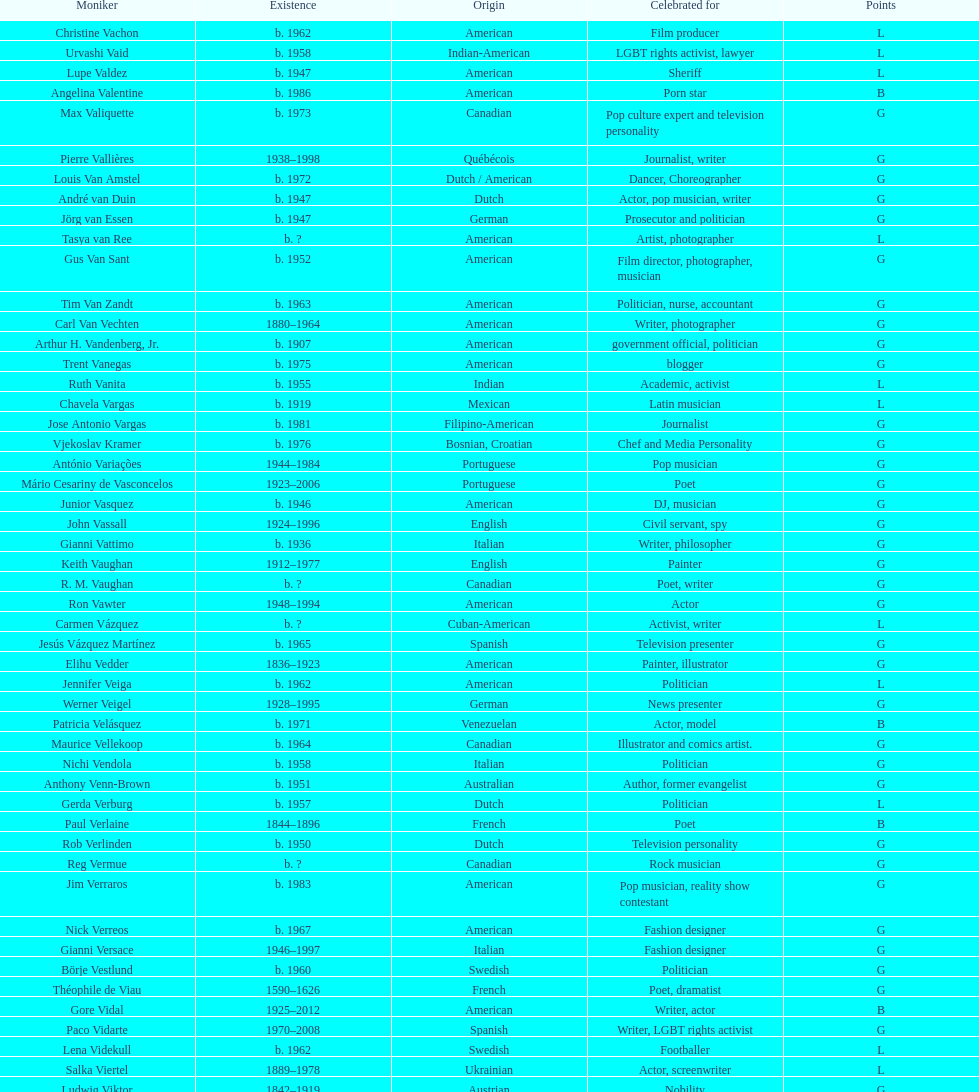Which is the previous name from lupe valdez Urvashi Vaid. 